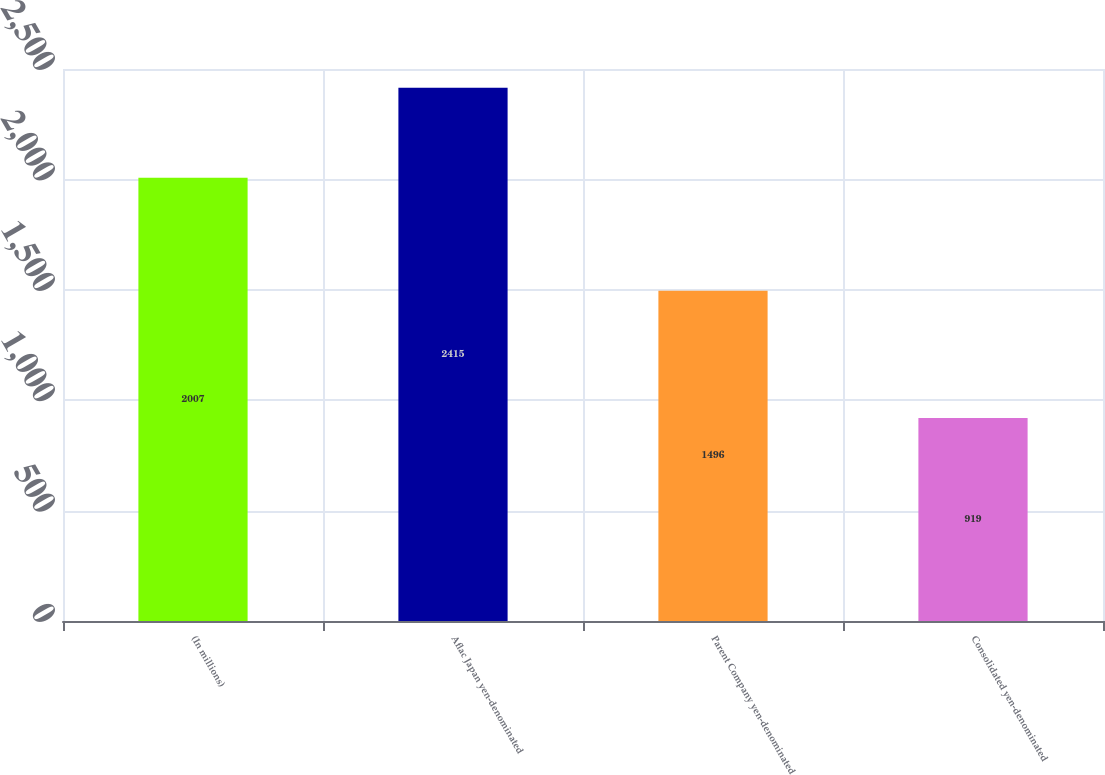Convert chart to OTSL. <chart><loc_0><loc_0><loc_500><loc_500><bar_chart><fcel>(In millions)<fcel>Aflac Japan yen-denominated<fcel>Parent Company yen-denominated<fcel>Consolidated yen-denominated<nl><fcel>2007<fcel>2415<fcel>1496<fcel>919<nl></chart> 